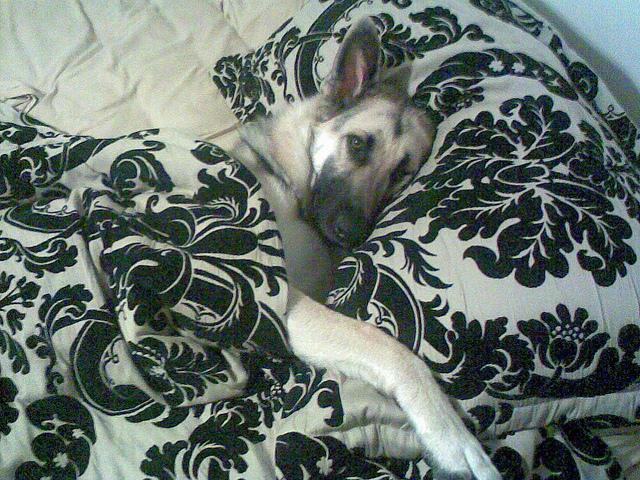How many of the train doors are green?
Give a very brief answer. 0. 